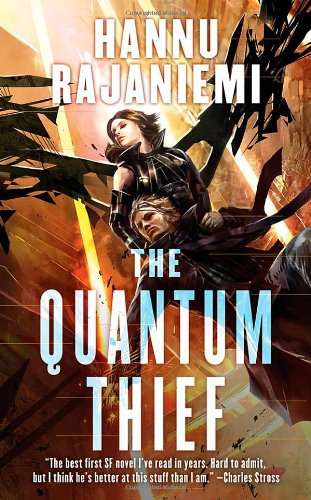Who is the author of this book? The author of the book shown, 'The Quantum Thief', is Hannu Rajaniemi, a renowned Finnish writer known for his intricate and thought-provoking science fiction. 